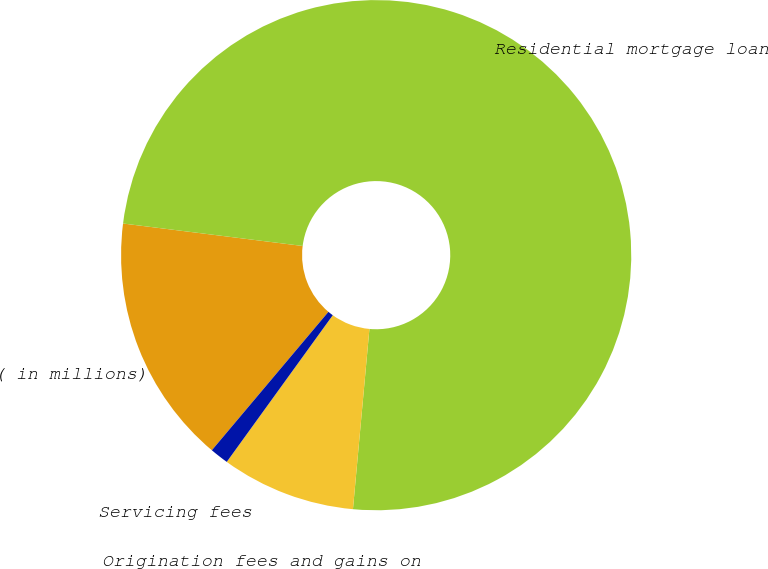Convert chart to OTSL. <chart><loc_0><loc_0><loc_500><loc_500><pie_chart><fcel>( in millions)<fcel>Residential mortgage loan<fcel>Origination fees and gains on<fcel>Servicing fees<nl><fcel>15.84%<fcel>74.47%<fcel>8.51%<fcel>1.18%<nl></chart> 